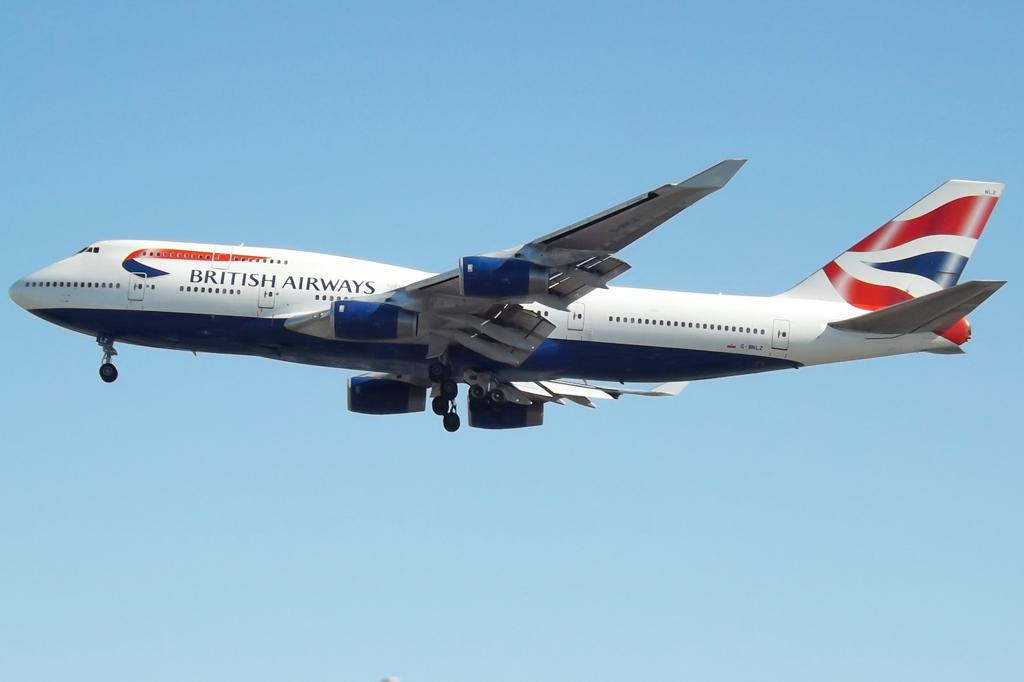Provide a one-sentence caption for the provided image. An airplane from British Airways in the sky with it. 